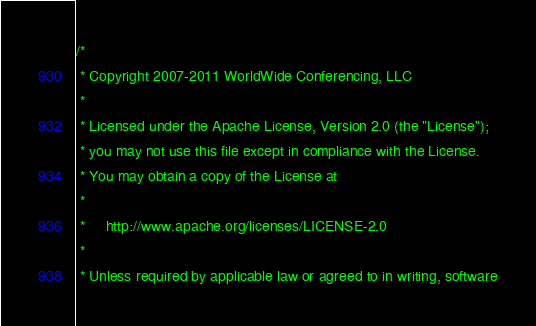<code> <loc_0><loc_0><loc_500><loc_500><_Scala_>/*
 * Copyright 2007-2011 WorldWide Conferencing, LLC
 *
 * Licensed under the Apache License, Version 2.0 (the "License");
 * you may not use this file except in compliance with the License.
 * You may obtain a copy of the License at
 *
 *     http://www.apache.org/licenses/LICENSE-2.0
 *
 * Unless required by applicable law or agreed to in writing, software</code> 